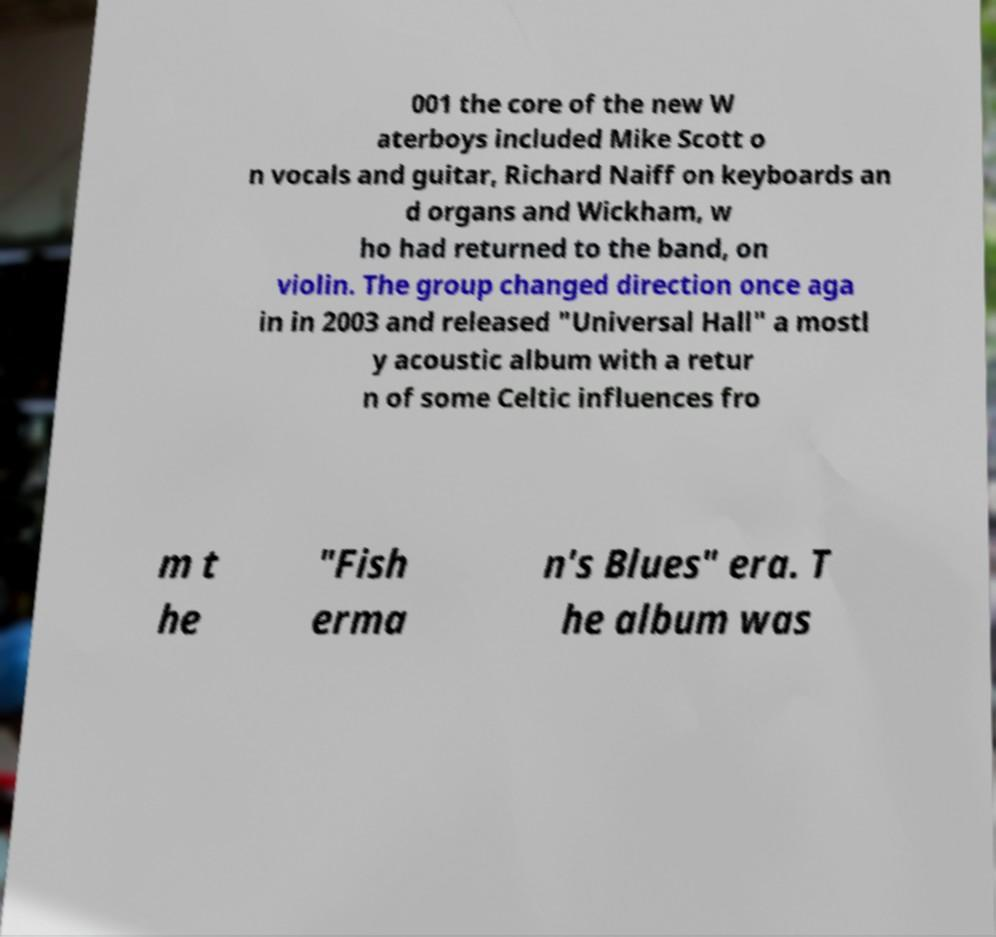Please read and relay the text visible in this image. What does it say? 001 the core of the new W aterboys included Mike Scott o n vocals and guitar, Richard Naiff on keyboards an d organs and Wickham, w ho had returned to the band, on violin. The group changed direction once aga in in 2003 and released "Universal Hall" a mostl y acoustic album with a retur n of some Celtic influences fro m t he "Fish erma n's Blues" era. T he album was 